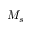Convert formula to latex. <formula><loc_0><loc_0><loc_500><loc_500>M _ { s }</formula> 